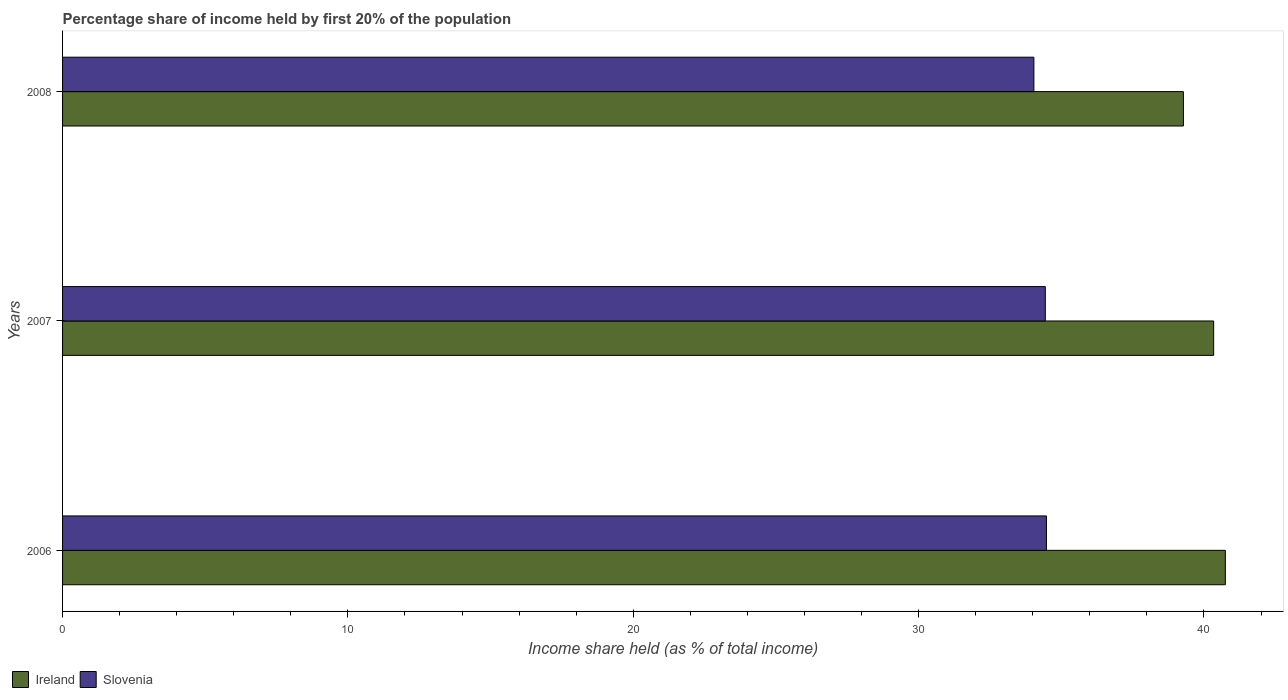Are the number of bars per tick equal to the number of legend labels?
Keep it short and to the point. Yes. Are the number of bars on each tick of the Y-axis equal?
Your answer should be very brief. Yes. How many bars are there on the 1st tick from the top?
Provide a short and direct response. 2. What is the label of the 3rd group of bars from the top?
Give a very brief answer. 2006. In how many cases, is the number of bars for a given year not equal to the number of legend labels?
Make the answer very short. 0. What is the share of income held by first 20% of the population in Ireland in 2007?
Offer a terse response. 40.34. Across all years, what is the maximum share of income held by first 20% of the population in Ireland?
Provide a short and direct response. 40.75. Across all years, what is the minimum share of income held by first 20% of the population in Slovenia?
Offer a terse response. 34.04. In which year was the share of income held by first 20% of the population in Ireland maximum?
Your answer should be compact. 2006. What is the total share of income held by first 20% of the population in Ireland in the graph?
Keep it short and to the point. 120.37. What is the difference between the share of income held by first 20% of the population in Ireland in 2006 and that in 2008?
Keep it short and to the point. 1.47. What is the difference between the share of income held by first 20% of the population in Slovenia in 2008 and the share of income held by first 20% of the population in Ireland in 2007?
Give a very brief answer. -6.3. What is the average share of income held by first 20% of the population in Slovenia per year?
Offer a terse response. 34.32. In the year 2007, what is the difference between the share of income held by first 20% of the population in Slovenia and share of income held by first 20% of the population in Ireland?
Your answer should be very brief. -5.9. In how many years, is the share of income held by first 20% of the population in Slovenia greater than 32 %?
Make the answer very short. 3. What is the ratio of the share of income held by first 20% of the population in Slovenia in 2006 to that in 2007?
Make the answer very short. 1. Is the share of income held by first 20% of the population in Slovenia in 2006 less than that in 2007?
Make the answer very short. No. What is the difference between the highest and the second highest share of income held by first 20% of the population in Slovenia?
Offer a terse response. 0.04. What is the difference between the highest and the lowest share of income held by first 20% of the population in Slovenia?
Your answer should be very brief. 0.44. Is the sum of the share of income held by first 20% of the population in Ireland in 2006 and 2008 greater than the maximum share of income held by first 20% of the population in Slovenia across all years?
Provide a short and direct response. Yes. What does the 1st bar from the top in 2007 represents?
Offer a terse response. Slovenia. What does the 2nd bar from the bottom in 2007 represents?
Make the answer very short. Slovenia. What is the difference between two consecutive major ticks on the X-axis?
Provide a succinct answer. 10. Does the graph contain any zero values?
Make the answer very short. No. Does the graph contain grids?
Keep it short and to the point. No. Where does the legend appear in the graph?
Offer a terse response. Bottom left. How many legend labels are there?
Ensure brevity in your answer.  2. What is the title of the graph?
Give a very brief answer. Percentage share of income held by first 20% of the population. What is the label or title of the X-axis?
Offer a terse response. Income share held (as % of total income). What is the label or title of the Y-axis?
Provide a succinct answer. Years. What is the Income share held (as % of total income) in Ireland in 2006?
Keep it short and to the point. 40.75. What is the Income share held (as % of total income) in Slovenia in 2006?
Your answer should be very brief. 34.48. What is the Income share held (as % of total income) of Ireland in 2007?
Ensure brevity in your answer.  40.34. What is the Income share held (as % of total income) in Slovenia in 2007?
Offer a very short reply. 34.44. What is the Income share held (as % of total income) of Ireland in 2008?
Your answer should be compact. 39.28. What is the Income share held (as % of total income) in Slovenia in 2008?
Make the answer very short. 34.04. Across all years, what is the maximum Income share held (as % of total income) of Ireland?
Your answer should be very brief. 40.75. Across all years, what is the maximum Income share held (as % of total income) of Slovenia?
Your response must be concise. 34.48. Across all years, what is the minimum Income share held (as % of total income) of Ireland?
Ensure brevity in your answer.  39.28. Across all years, what is the minimum Income share held (as % of total income) in Slovenia?
Offer a terse response. 34.04. What is the total Income share held (as % of total income) of Ireland in the graph?
Your response must be concise. 120.37. What is the total Income share held (as % of total income) of Slovenia in the graph?
Ensure brevity in your answer.  102.96. What is the difference between the Income share held (as % of total income) in Ireland in 2006 and that in 2007?
Make the answer very short. 0.41. What is the difference between the Income share held (as % of total income) of Ireland in 2006 and that in 2008?
Provide a short and direct response. 1.47. What is the difference between the Income share held (as % of total income) in Slovenia in 2006 and that in 2008?
Keep it short and to the point. 0.44. What is the difference between the Income share held (as % of total income) of Ireland in 2007 and that in 2008?
Your response must be concise. 1.06. What is the difference between the Income share held (as % of total income) of Slovenia in 2007 and that in 2008?
Offer a very short reply. 0.4. What is the difference between the Income share held (as % of total income) in Ireland in 2006 and the Income share held (as % of total income) in Slovenia in 2007?
Your answer should be compact. 6.31. What is the difference between the Income share held (as % of total income) of Ireland in 2006 and the Income share held (as % of total income) of Slovenia in 2008?
Provide a short and direct response. 6.71. What is the difference between the Income share held (as % of total income) of Ireland in 2007 and the Income share held (as % of total income) of Slovenia in 2008?
Your answer should be very brief. 6.3. What is the average Income share held (as % of total income) of Ireland per year?
Provide a succinct answer. 40.12. What is the average Income share held (as % of total income) of Slovenia per year?
Provide a succinct answer. 34.32. In the year 2006, what is the difference between the Income share held (as % of total income) in Ireland and Income share held (as % of total income) in Slovenia?
Make the answer very short. 6.27. In the year 2008, what is the difference between the Income share held (as % of total income) in Ireland and Income share held (as % of total income) in Slovenia?
Give a very brief answer. 5.24. What is the ratio of the Income share held (as % of total income) in Ireland in 2006 to that in 2007?
Give a very brief answer. 1.01. What is the ratio of the Income share held (as % of total income) in Ireland in 2006 to that in 2008?
Your answer should be very brief. 1.04. What is the ratio of the Income share held (as % of total income) in Slovenia in 2006 to that in 2008?
Give a very brief answer. 1.01. What is the ratio of the Income share held (as % of total income) in Slovenia in 2007 to that in 2008?
Ensure brevity in your answer.  1.01. What is the difference between the highest and the second highest Income share held (as % of total income) in Ireland?
Your response must be concise. 0.41. What is the difference between the highest and the second highest Income share held (as % of total income) of Slovenia?
Offer a very short reply. 0.04. What is the difference between the highest and the lowest Income share held (as % of total income) of Ireland?
Your response must be concise. 1.47. What is the difference between the highest and the lowest Income share held (as % of total income) of Slovenia?
Your response must be concise. 0.44. 